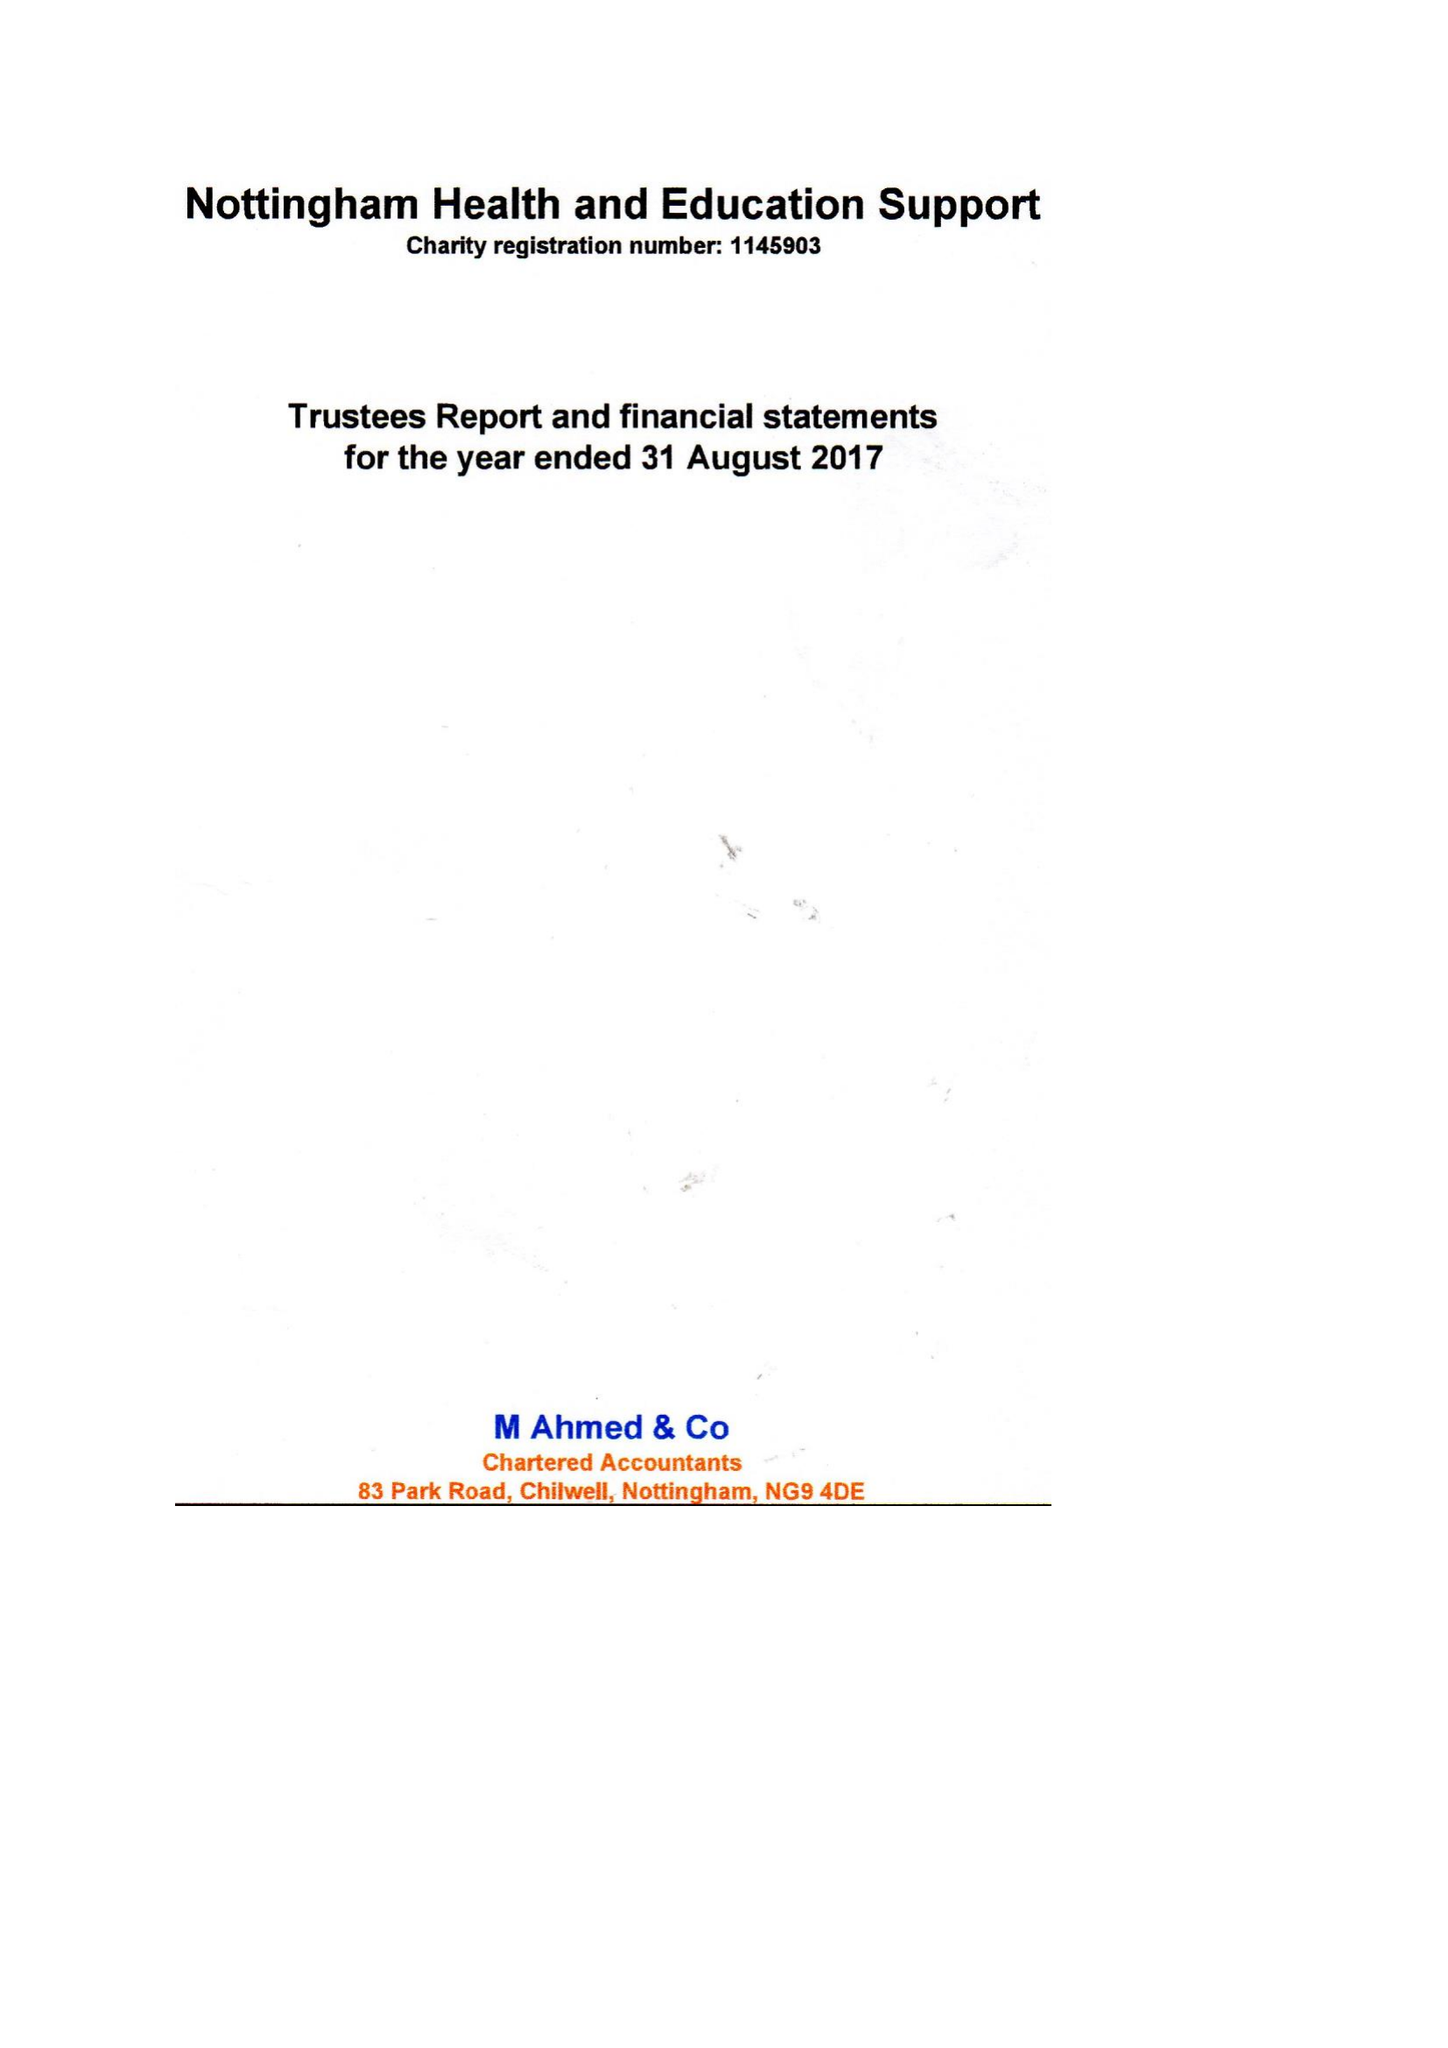What is the value for the spending_annually_in_british_pounds?
Answer the question using a single word or phrase. 76576.00 